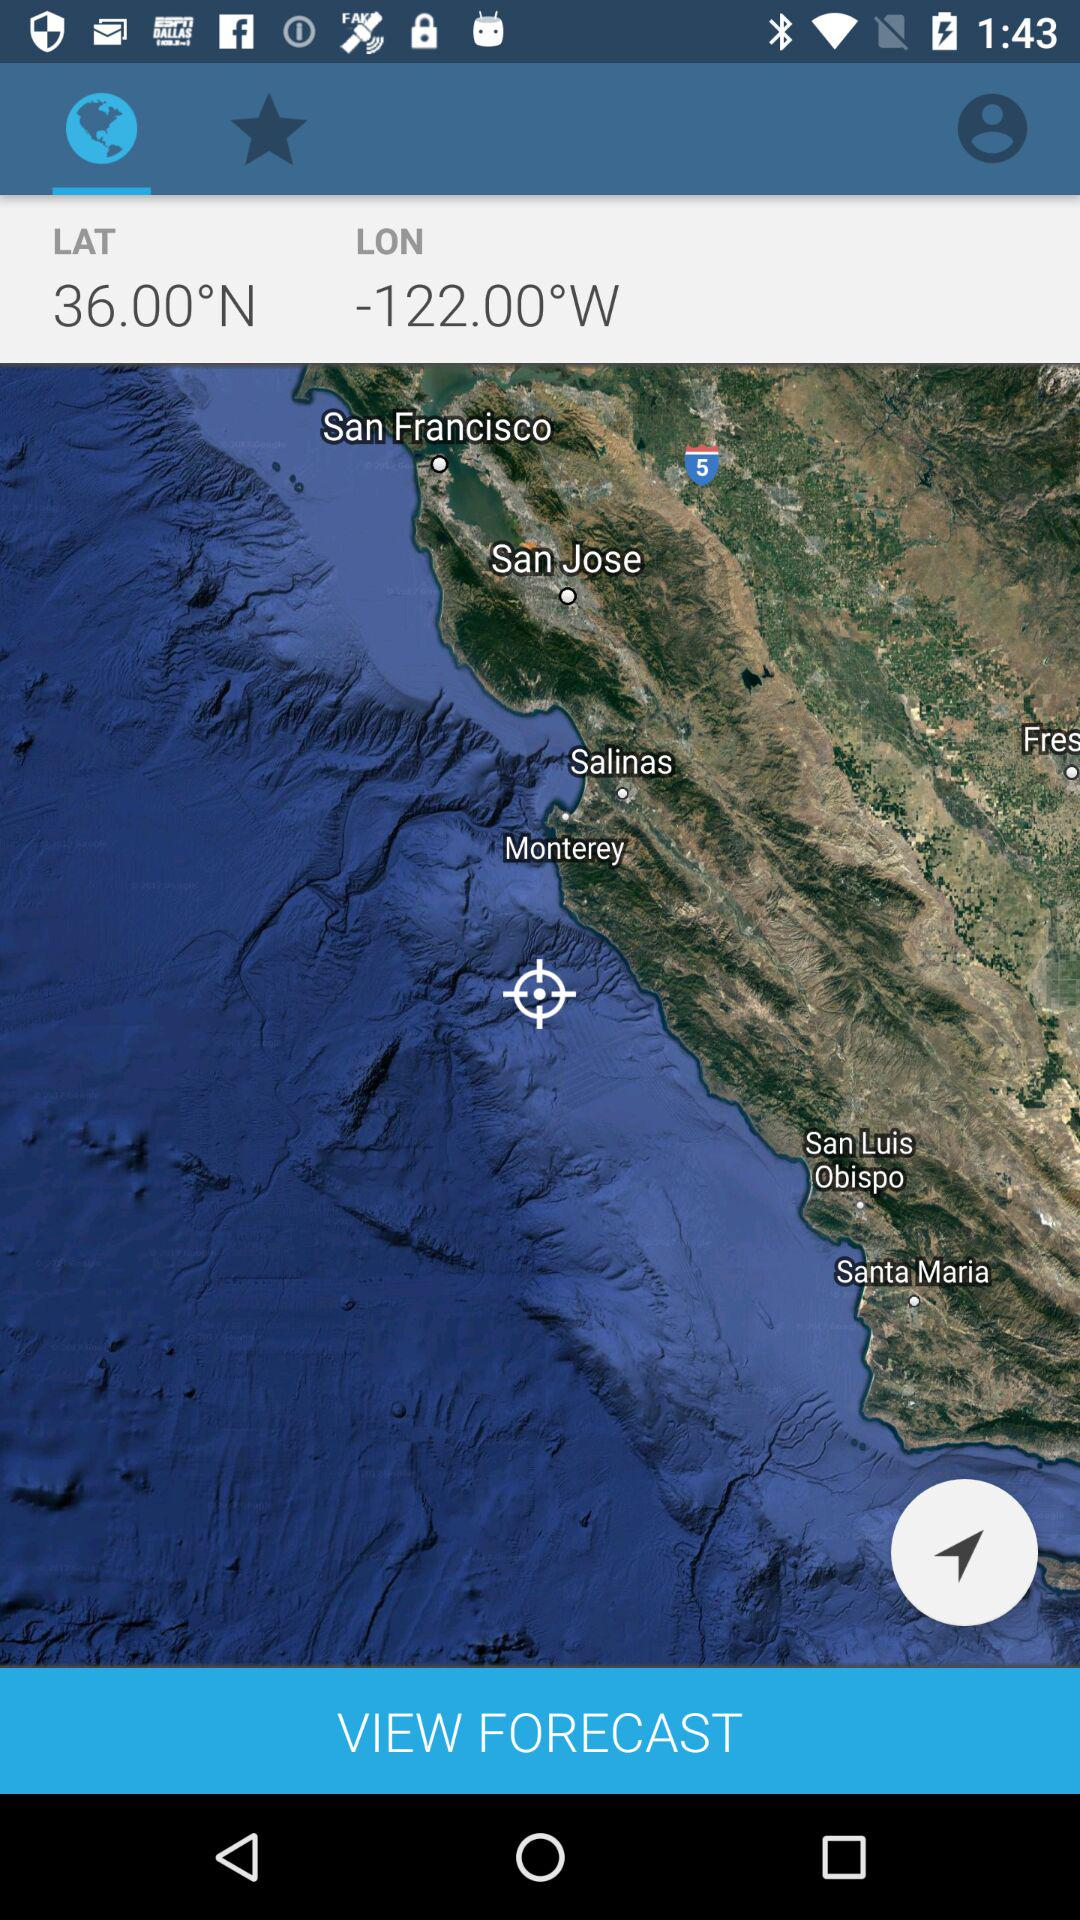What's the latitude? The latitude is 36.00°N. 